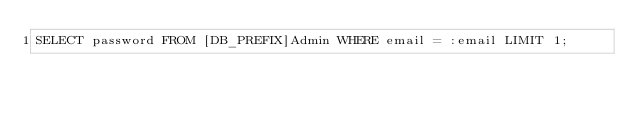Convert code to text. <code><loc_0><loc_0><loc_500><loc_500><_SQL_>SELECT password FROM [DB_PREFIX]Admin WHERE email = :email LIMIT 1;</code> 